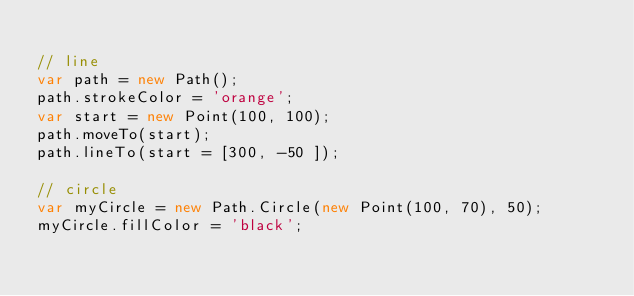Convert code to text. <code><loc_0><loc_0><loc_500><loc_500><_JavaScript_>
// line
var path = new Path();
path.strokeColor = 'orange';
var start = new Point(100, 100);
path.moveTo(start);
path.lineTo(start = [300, -50 ]);

// circle
var myCircle = new Path.Circle(new Point(100, 70), 50);
myCircle.fillColor = 'black';
  </code> 